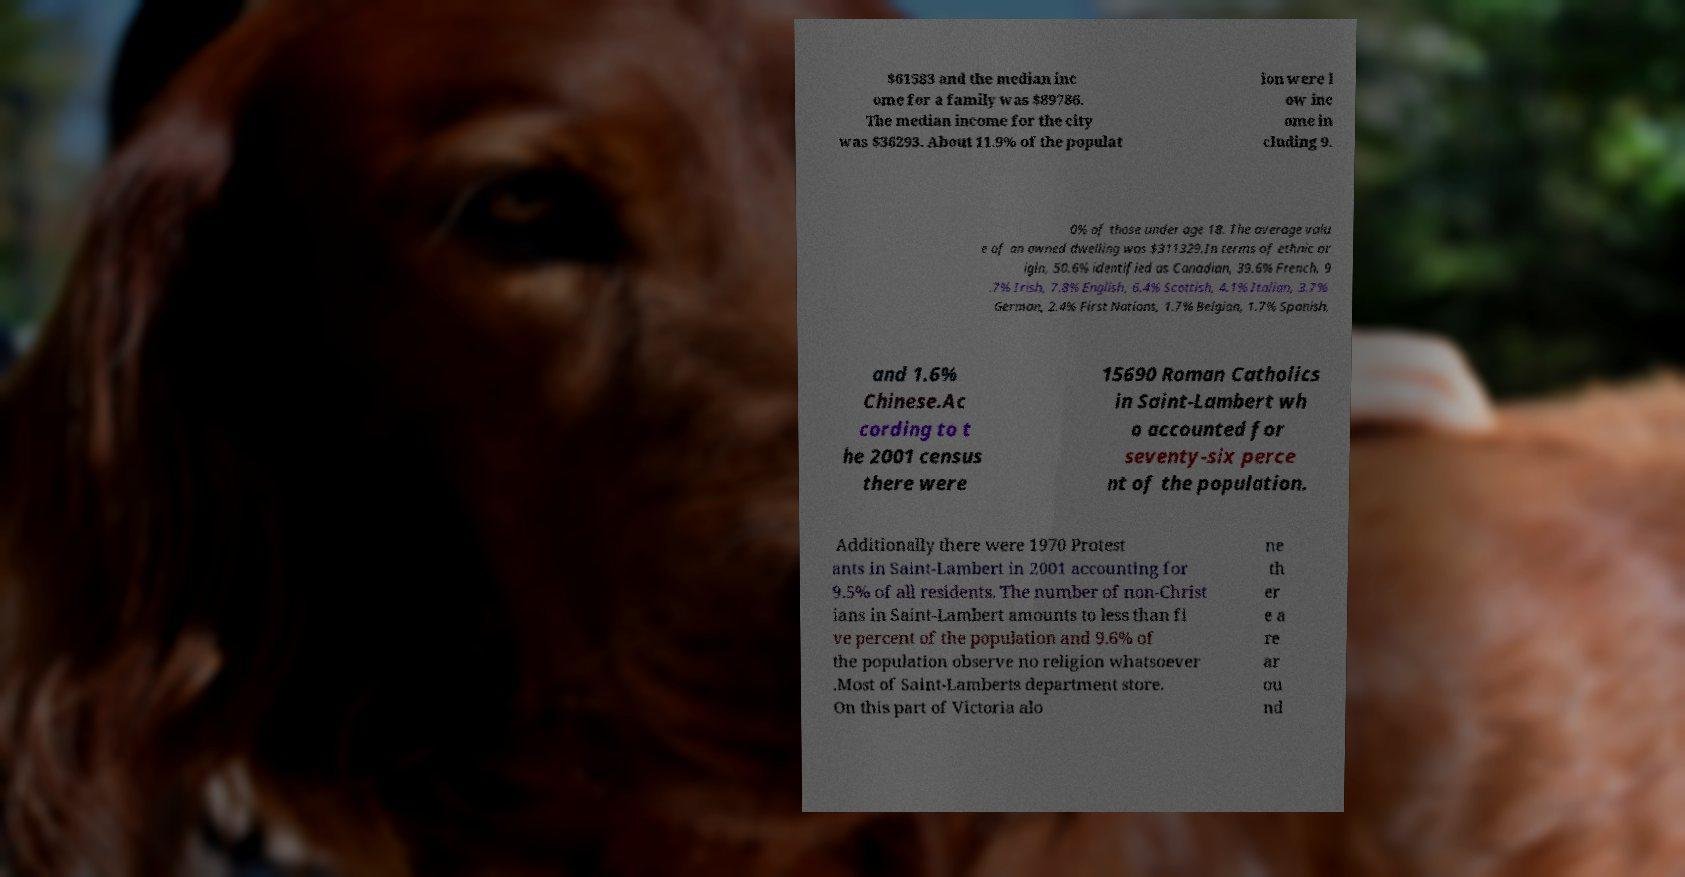Could you extract and type out the text from this image? $61583 and the median inc ome for a family was $89786. The median income for the city was $36293. About 11.9% of the populat ion were l ow inc ome in cluding 9. 0% of those under age 18. The average valu e of an owned dwelling was $311329.In terms of ethnic or igin, 50.6% identified as Canadian, 39.6% French, 9 .7% Irish, 7.8% English, 6.4% Scottish, 4.1% Italian, 3.7% German, 2.4% First Nations, 1.7% Belgian, 1.7% Spanish, and 1.6% Chinese.Ac cording to t he 2001 census there were 15690 Roman Catholics in Saint-Lambert wh o accounted for seventy-six perce nt of the population. Additionally there were 1970 Protest ants in Saint-Lambert in 2001 accounting for 9.5% of all residents. The number of non-Christ ians in Saint-Lambert amounts to less than fi ve percent of the population and 9.6% of the population observe no religion whatsoever .Most of Saint-Lamberts department store. On this part of Victoria alo ne th er e a re ar ou nd 